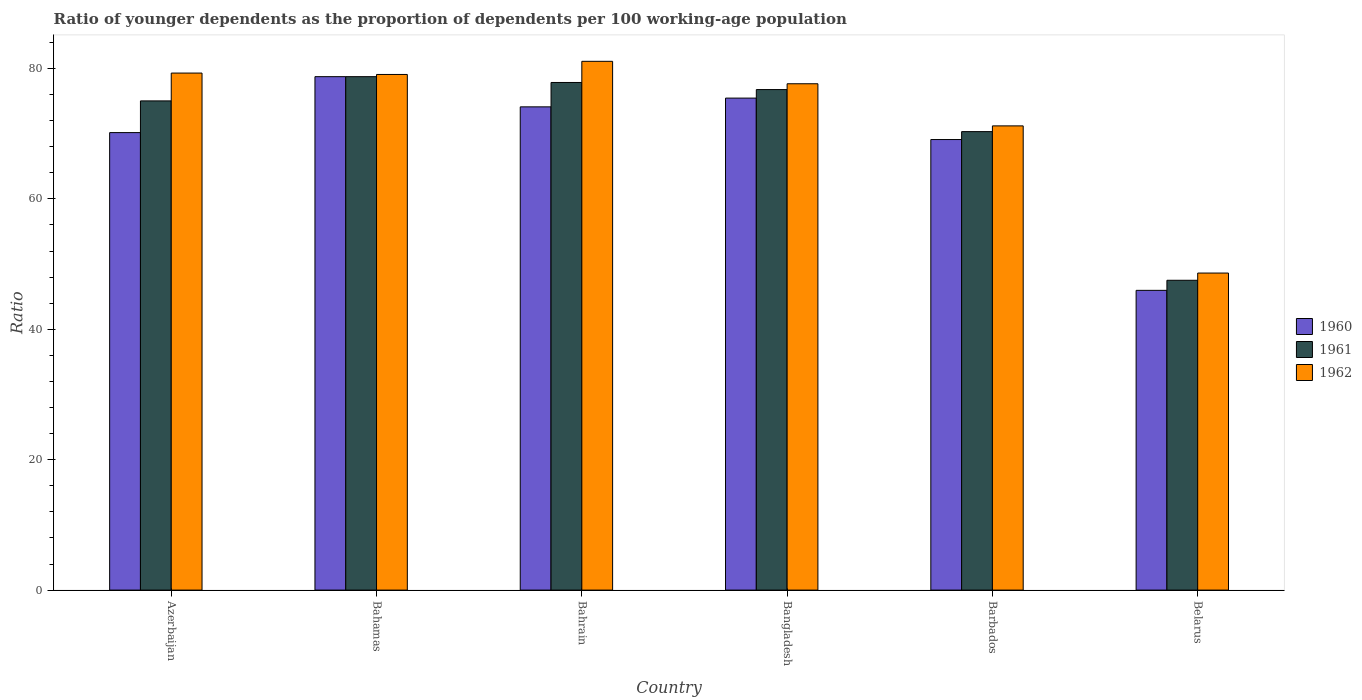How many groups of bars are there?
Give a very brief answer. 6. Are the number of bars per tick equal to the number of legend labels?
Your answer should be compact. Yes. How many bars are there on the 1st tick from the right?
Provide a succinct answer. 3. What is the label of the 4th group of bars from the left?
Offer a very short reply. Bangladesh. In how many cases, is the number of bars for a given country not equal to the number of legend labels?
Offer a terse response. 0. What is the age dependency ratio(young) in 1962 in Barbados?
Your answer should be very brief. 71.2. Across all countries, what is the maximum age dependency ratio(young) in 1960?
Your answer should be very brief. 78.75. Across all countries, what is the minimum age dependency ratio(young) in 1961?
Your answer should be compact. 47.52. In which country was the age dependency ratio(young) in 1961 maximum?
Your response must be concise. Bahamas. In which country was the age dependency ratio(young) in 1961 minimum?
Provide a short and direct response. Belarus. What is the total age dependency ratio(young) in 1960 in the graph?
Provide a short and direct response. 413.56. What is the difference between the age dependency ratio(young) in 1961 in Azerbaijan and that in Bangladesh?
Your answer should be very brief. -1.74. What is the difference between the age dependency ratio(young) in 1962 in Barbados and the age dependency ratio(young) in 1961 in Azerbaijan?
Your answer should be very brief. -3.83. What is the average age dependency ratio(young) in 1960 per country?
Your response must be concise. 68.93. What is the difference between the age dependency ratio(young) of/in 1960 and age dependency ratio(young) of/in 1961 in Belarus?
Offer a terse response. -1.55. What is the ratio of the age dependency ratio(young) in 1961 in Bahrain to that in Bangladesh?
Make the answer very short. 1.01. Is the difference between the age dependency ratio(young) in 1960 in Bangladesh and Belarus greater than the difference between the age dependency ratio(young) in 1961 in Bangladesh and Belarus?
Ensure brevity in your answer.  Yes. What is the difference between the highest and the second highest age dependency ratio(young) in 1960?
Your answer should be compact. -1.34. What is the difference between the highest and the lowest age dependency ratio(young) in 1962?
Provide a short and direct response. 32.48. In how many countries, is the age dependency ratio(young) in 1962 greater than the average age dependency ratio(young) in 1962 taken over all countries?
Make the answer very short. 4. Is the sum of the age dependency ratio(young) in 1962 in Azerbaijan and Bahrain greater than the maximum age dependency ratio(young) in 1960 across all countries?
Offer a very short reply. Yes. Is it the case that in every country, the sum of the age dependency ratio(young) in 1960 and age dependency ratio(young) in 1962 is greater than the age dependency ratio(young) in 1961?
Give a very brief answer. Yes. Are all the bars in the graph horizontal?
Offer a very short reply. No. What is the difference between two consecutive major ticks on the Y-axis?
Your answer should be compact. 20. Are the values on the major ticks of Y-axis written in scientific E-notation?
Your answer should be compact. No. Does the graph contain grids?
Provide a succinct answer. No. Where does the legend appear in the graph?
Provide a succinct answer. Center right. How are the legend labels stacked?
Provide a succinct answer. Vertical. What is the title of the graph?
Keep it short and to the point. Ratio of younger dependents as the proportion of dependents per 100 working-age population. Does "1991" appear as one of the legend labels in the graph?
Your answer should be compact. No. What is the label or title of the Y-axis?
Your answer should be compact. Ratio. What is the Ratio of 1960 in Azerbaijan?
Offer a terse response. 70.17. What is the Ratio of 1961 in Azerbaijan?
Your response must be concise. 75.03. What is the Ratio of 1962 in Azerbaijan?
Provide a short and direct response. 79.3. What is the Ratio in 1960 in Bahamas?
Your answer should be compact. 78.75. What is the Ratio of 1961 in Bahamas?
Provide a short and direct response. 78.75. What is the Ratio in 1962 in Bahamas?
Keep it short and to the point. 79.08. What is the Ratio of 1960 in Bahrain?
Offer a terse response. 74.12. What is the Ratio of 1961 in Bahrain?
Make the answer very short. 77.85. What is the Ratio of 1962 in Bahrain?
Your answer should be compact. 81.1. What is the Ratio of 1960 in Bangladesh?
Make the answer very short. 75.46. What is the Ratio of 1961 in Bangladesh?
Make the answer very short. 76.77. What is the Ratio of 1962 in Bangladesh?
Offer a terse response. 77.66. What is the Ratio in 1960 in Barbados?
Give a very brief answer. 69.1. What is the Ratio of 1961 in Barbados?
Keep it short and to the point. 70.32. What is the Ratio in 1962 in Barbados?
Keep it short and to the point. 71.2. What is the Ratio of 1960 in Belarus?
Offer a very short reply. 45.97. What is the Ratio of 1961 in Belarus?
Your answer should be compact. 47.52. What is the Ratio in 1962 in Belarus?
Your response must be concise. 48.62. Across all countries, what is the maximum Ratio of 1960?
Provide a succinct answer. 78.75. Across all countries, what is the maximum Ratio in 1961?
Ensure brevity in your answer.  78.75. Across all countries, what is the maximum Ratio in 1962?
Provide a short and direct response. 81.1. Across all countries, what is the minimum Ratio of 1960?
Offer a very short reply. 45.97. Across all countries, what is the minimum Ratio of 1961?
Keep it short and to the point. 47.52. Across all countries, what is the minimum Ratio in 1962?
Provide a short and direct response. 48.62. What is the total Ratio of 1960 in the graph?
Give a very brief answer. 413.56. What is the total Ratio in 1961 in the graph?
Offer a terse response. 426.23. What is the total Ratio in 1962 in the graph?
Keep it short and to the point. 436.96. What is the difference between the Ratio in 1960 in Azerbaijan and that in Bahamas?
Give a very brief answer. -8.58. What is the difference between the Ratio of 1961 in Azerbaijan and that in Bahamas?
Give a very brief answer. -3.72. What is the difference between the Ratio of 1962 in Azerbaijan and that in Bahamas?
Your answer should be compact. 0.21. What is the difference between the Ratio of 1960 in Azerbaijan and that in Bahrain?
Ensure brevity in your answer.  -3.95. What is the difference between the Ratio in 1961 in Azerbaijan and that in Bahrain?
Provide a short and direct response. -2.83. What is the difference between the Ratio of 1962 in Azerbaijan and that in Bahrain?
Your answer should be very brief. -1.8. What is the difference between the Ratio in 1960 in Azerbaijan and that in Bangladesh?
Your answer should be compact. -5.29. What is the difference between the Ratio in 1961 in Azerbaijan and that in Bangladesh?
Offer a terse response. -1.74. What is the difference between the Ratio of 1962 in Azerbaijan and that in Bangladesh?
Provide a short and direct response. 1.64. What is the difference between the Ratio in 1960 in Azerbaijan and that in Barbados?
Offer a terse response. 1.06. What is the difference between the Ratio in 1961 in Azerbaijan and that in Barbados?
Make the answer very short. 4.71. What is the difference between the Ratio in 1962 in Azerbaijan and that in Barbados?
Offer a terse response. 8.1. What is the difference between the Ratio in 1960 in Azerbaijan and that in Belarus?
Your answer should be very brief. 24.2. What is the difference between the Ratio of 1961 in Azerbaijan and that in Belarus?
Ensure brevity in your answer.  27.51. What is the difference between the Ratio in 1962 in Azerbaijan and that in Belarus?
Make the answer very short. 30.67. What is the difference between the Ratio of 1960 in Bahamas and that in Bahrain?
Make the answer very short. 4.63. What is the difference between the Ratio in 1961 in Bahamas and that in Bahrain?
Ensure brevity in your answer.  0.89. What is the difference between the Ratio in 1962 in Bahamas and that in Bahrain?
Offer a very short reply. -2.02. What is the difference between the Ratio of 1960 in Bahamas and that in Bangladesh?
Provide a succinct answer. 3.29. What is the difference between the Ratio in 1961 in Bahamas and that in Bangladesh?
Provide a succinct answer. 1.98. What is the difference between the Ratio of 1962 in Bahamas and that in Bangladesh?
Make the answer very short. 1.43. What is the difference between the Ratio in 1960 in Bahamas and that in Barbados?
Your answer should be compact. 9.64. What is the difference between the Ratio of 1961 in Bahamas and that in Barbados?
Offer a very short reply. 8.43. What is the difference between the Ratio in 1962 in Bahamas and that in Barbados?
Offer a very short reply. 7.89. What is the difference between the Ratio in 1960 in Bahamas and that in Belarus?
Provide a succinct answer. 32.77. What is the difference between the Ratio in 1961 in Bahamas and that in Belarus?
Your answer should be very brief. 31.23. What is the difference between the Ratio of 1962 in Bahamas and that in Belarus?
Ensure brevity in your answer.  30.46. What is the difference between the Ratio of 1960 in Bahrain and that in Bangladesh?
Keep it short and to the point. -1.34. What is the difference between the Ratio in 1961 in Bahrain and that in Bangladesh?
Offer a terse response. 1.09. What is the difference between the Ratio of 1962 in Bahrain and that in Bangladesh?
Your answer should be compact. 3.44. What is the difference between the Ratio in 1960 in Bahrain and that in Barbados?
Provide a succinct answer. 5.01. What is the difference between the Ratio of 1961 in Bahrain and that in Barbados?
Provide a short and direct response. 7.54. What is the difference between the Ratio of 1962 in Bahrain and that in Barbados?
Offer a very short reply. 9.9. What is the difference between the Ratio in 1960 in Bahrain and that in Belarus?
Provide a short and direct response. 28.14. What is the difference between the Ratio in 1961 in Bahrain and that in Belarus?
Your answer should be compact. 30.34. What is the difference between the Ratio in 1962 in Bahrain and that in Belarus?
Give a very brief answer. 32.48. What is the difference between the Ratio of 1960 in Bangladesh and that in Barbados?
Provide a succinct answer. 6.36. What is the difference between the Ratio of 1961 in Bangladesh and that in Barbados?
Your response must be concise. 6.45. What is the difference between the Ratio in 1962 in Bangladesh and that in Barbados?
Ensure brevity in your answer.  6.46. What is the difference between the Ratio of 1960 in Bangladesh and that in Belarus?
Make the answer very short. 29.49. What is the difference between the Ratio of 1961 in Bangladesh and that in Belarus?
Your answer should be compact. 29.25. What is the difference between the Ratio in 1962 in Bangladesh and that in Belarus?
Ensure brevity in your answer.  29.03. What is the difference between the Ratio in 1960 in Barbados and that in Belarus?
Your answer should be compact. 23.13. What is the difference between the Ratio of 1961 in Barbados and that in Belarus?
Keep it short and to the point. 22.8. What is the difference between the Ratio of 1962 in Barbados and that in Belarus?
Make the answer very short. 22.57. What is the difference between the Ratio in 1960 in Azerbaijan and the Ratio in 1961 in Bahamas?
Your answer should be compact. -8.58. What is the difference between the Ratio of 1960 in Azerbaijan and the Ratio of 1962 in Bahamas?
Provide a succinct answer. -8.92. What is the difference between the Ratio of 1961 in Azerbaijan and the Ratio of 1962 in Bahamas?
Provide a succinct answer. -4.06. What is the difference between the Ratio in 1960 in Azerbaijan and the Ratio in 1961 in Bahrain?
Offer a terse response. -7.69. What is the difference between the Ratio of 1960 in Azerbaijan and the Ratio of 1962 in Bahrain?
Your response must be concise. -10.93. What is the difference between the Ratio of 1961 in Azerbaijan and the Ratio of 1962 in Bahrain?
Offer a terse response. -6.07. What is the difference between the Ratio of 1960 in Azerbaijan and the Ratio of 1961 in Bangladesh?
Provide a short and direct response. -6.6. What is the difference between the Ratio in 1960 in Azerbaijan and the Ratio in 1962 in Bangladesh?
Offer a very short reply. -7.49. What is the difference between the Ratio in 1961 in Azerbaijan and the Ratio in 1962 in Bangladesh?
Provide a succinct answer. -2.63. What is the difference between the Ratio in 1960 in Azerbaijan and the Ratio in 1961 in Barbados?
Keep it short and to the point. -0.15. What is the difference between the Ratio of 1960 in Azerbaijan and the Ratio of 1962 in Barbados?
Your answer should be compact. -1.03. What is the difference between the Ratio of 1961 in Azerbaijan and the Ratio of 1962 in Barbados?
Ensure brevity in your answer.  3.83. What is the difference between the Ratio of 1960 in Azerbaijan and the Ratio of 1961 in Belarus?
Provide a succinct answer. 22.65. What is the difference between the Ratio in 1960 in Azerbaijan and the Ratio in 1962 in Belarus?
Offer a terse response. 21.54. What is the difference between the Ratio in 1961 in Azerbaijan and the Ratio in 1962 in Belarus?
Keep it short and to the point. 26.4. What is the difference between the Ratio in 1960 in Bahamas and the Ratio in 1961 in Bahrain?
Provide a succinct answer. 0.89. What is the difference between the Ratio in 1960 in Bahamas and the Ratio in 1962 in Bahrain?
Provide a succinct answer. -2.35. What is the difference between the Ratio of 1961 in Bahamas and the Ratio of 1962 in Bahrain?
Your response must be concise. -2.35. What is the difference between the Ratio of 1960 in Bahamas and the Ratio of 1961 in Bangladesh?
Ensure brevity in your answer.  1.98. What is the difference between the Ratio of 1960 in Bahamas and the Ratio of 1962 in Bangladesh?
Keep it short and to the point. 1.09. What is the difference between the Ratio of 1961 in Bahamas and the Ratio of 1962 in Bangladesh?
Your answer should be very brief. 1.09. What is the difference between the Ratio in 1960 in Bahamas and the Ratio in 1961 in Barbados?
Give a very brief answer. 8.43. What is the difference between the Ratio of 1960 in Bahamas and the Ratio of 1962 in Barbados?
Provide a short and direct response. 7.55. What is the difference between the Ratio of 1961 in Bahamas and the Ratio of 1962 in Barbados?
Provide a succinct answer. 7.55. What is the difference between the Ratio in 1960 in Bahamas and the Ratio in 1961 in Belarus?
Keep it short and to the point. 31.23. What is the difference between the Ratio in 1960 in Bahamas and the Ratio in 1962 in Belarus?
Make the answer very short. 30.12. What is the difference between the Ratio of 1961 in Bahamas and the Ratio of 1962 in Belarus?
Offer a very short reply. 30.12. What is the difference between the Ratio in 1960 in Bahrain and the Ratio in 1961 in Bangladesh?
Provide a succinct answer. -2.65. What is the difference between the Ratio of 1960 in Bahrain and the Ratio of 1962 in Bangladesh?
Provide a succinct answer. -3.54. What is the difference between the Ratio in 1961 in Bahrain and the Ratio in 1962 in Bangladesh?
Give a very brief answer. 0.2. What is the difference between the Ratio of 1960 in Bahrain and the Ratio of 1961 in Barbados?
Give a very brief answer. 3.8. What is the difference between the Ratio in 1960 in Bahrain and the Ratio in 1962 in Barbados?
Offer a terse response. 2.92. What is the difference between the Ratio in 1961 in Bahrain and the Ratio in 1962 in Barbados?
Give a very brief answer. 6.66. What is the difference between the Ratio in 1960 in Bahrain and the Ratio in 1961 in Belarus?
Your answer should be very brief. 26.6. What is the difference between the Ratio of 1960 in Bahrain and the Ratio of 1962 in Belarus?
Ensure brevity in your answer.  25.49. What is the difference between the Ratio of 1961 in Bahrain and the Ratio of 1962 in Belarus?
Provide a succinct answer. 29.23. What is the difference between the Ratio of 1960 in Bangladesh and the Ratio of 1961 in Barbados?
Make the answer very short. 5.14. What is the difference between the Ratio of 1960 in Bangladesh and the Ratio of 1962 in Barbados?
Ensure brevity in your answer.  4.26. What is the difference between the Ratio in 1961 in Bangladesh and the Ratio in 1962 in Barbados?
Your answer should be very brief. 5.57. What is the difference between the Ratio of 1960 in Bangladesh and the Ratio of 1961 in Belarus?
Give a very brief answer. 27.94. What is the difference between the Ratio in 1960 in Bangladesh and the Ratio in 1962 in Belarus?
Your answer should be compact. 26.83. What is the difference between the Ratio in 1961 in Bangladesh and the Ratio in 1962 in Belarus?
Give a very brief answer. 28.14. What is the difference between the Ratio of 1960 in Barbados and the Ratio of 1961 in Belarus?
Offer a very short reply. 21.58. What is the difference between the Ratio of 1960 in Barbados and the Ratio of 1962 in Belarus?
Give a very brief answer. 20.48. What is the difference between the Ratio in 1961 in Barbados and the Ratio in 1962 in Belarus?
Your response must be concise. 21.69. What is the average Ratio of 1960 per country?
Your response must be concise. 68.93. What is the average Ratio in 1961 per country?
Give a very brief answer. 71.04. What is the average Ratio in 1962 per country?
Provide a short and direct response. 72.83. What is the difference between the Ratio in 1960 and Ratio in 1961 in Azerbaijan?
Your answer should be very brief. -4.86. What is the difference between the Ratio of 1960 and Ratio of 1962 in Azerbaijan?
Offer a very short reply. -9.13. What is the difference between the Ratio of 1961 and Ratio of 1962 in Azerbaijan?
Your response must be concise. -4.27. What is the difference between the Ratio in 1960 and Ratio in 1961 in Bahamas?
Your answer should be very brief. 0. What is the difference between the Ratio of 1960 and Ratio of 1962 in Bahamas?
Provide a short and direct response. -0.34. What is the difference between the Ratio in 1961 and Ratio in 1962 in Bahamas?
Ensure brevity in your answer.  -0.34. What is the difference between the Ratio in 1960 and Ratio in 1961 in Bahrain?
Offer a terse response. -3.74. What is the difference between the Ratio in 1960 and Ratio in 1962 in Bahrain?
Your response must be concise. -6.98. What is the difference between the Ratio of 1961 and Ratio of 1962 in Bahrain?
Give a very brief answer. -3.25. What is the difference between the Ratio in 1960 and Ratio in 1961 in Bangladesh?
Your response must be concise. -1.31. What is the difference between the Ratio in 1960 and Ratio in 1962 in Bangladesh?
Offer a terse response. -2.2. What is the difference between the Ratio in 1961 and Ratio in 1962 in Bangladesh?
Your response must be concise. -0.89. What is the difference between the Ratio in 1960 and Ratio in 1961 in Barbados?
Provide a succinct answer. -1.22. What is the difference between the Ratio in 1960 and Ratio in 1962 in Barbados?
Provide a short and direct response. -2.1. What is the difference between the Ratio in 1961 and Ratio in 1962 in Barbados?
Your answer should be compact. -0.88. What is the difference between the Ratio in 1960 and Ratio in 1961 in Belarus?
Make the answer very short. -1.55. What is the difference between the Ratio in 1960 and Ratio in 1962 in Belarus?
Give a very brief answer. -2.65. What is the difference between the Ratio in 1961 and Ratio in 1962 in Belarus?
Ensure brevity in your answer.  -1.11. What is the ratio of the Ratio in 1960 in Azerbaijan to that in Bahamas?
Keep it short and to the point. 0.89. What is the ratio of the Ratio of 1961 in Azerbaijan to that in Bahamas?
Ensure brevity in your answer.  0.95. What is the ratio of the Ratio of 1960 in Azerbaijan to that in Bahrain?
Make the answer very short. 0.95. What is the ratio of the Ratio in 1961 in Azerbaijan to that in Bahrain?
Provide a short and direct response. 0.96. What is the ratio of the Ratio of 1962 in Azerbaijan to that in Bahrain?
Provide a short and direct response. 0.98. What is the ratio of the Ratio of 1960 in Azerbaijan to that in Bangladesh?
Offer a very short reply. 0.93. What is the ratio of the Ratio of 1961 in Azerbaijan to that in Bangladesh?
Provide a short and direct response. 0.98. What is the ratio of the Ratio in 1962 in Azerbaijan to that in Bangladesh?
Offer a terse response. 1.02. What is the ratio of the Ratio of 1960 in Azerbaijan to that in Barbados?
Keep it short and to the point. 1.02. What is the ratio of the Ratio of 1961 in Azerbaijan to that in Barbados?
Your answer should be very brief. 1.07. What is the ratio of the Ratio of 1962 in Azerbaijan to that in Barbados?
Make the answer very short. 1.11. What is the ratio of the Ratio of 1960 in Azerbaijan to that in Belarus?
Offer a very short reply. 1.53. What is the ratio of the Ratio in 1961 in Azerbaijan to that in Belarus?
Offer a terse response. 1.58. What is the ratio of the Ratio of 1962 in Azerbaijan to that in Belarus?
Offer a terse response. 1.63. What is the ratio of the Ratio of 1960 in Bahamas to that in Bahrain?
Give a very brief answer. 1.06. What is the ratio of the Ratio of 1961 in Bahamas to that in Bahrain?
Provide a succinct answer. 1.01. What is the ratio of the Ratio in 1962 in Bahamas to that in Bahrain?
Your answer should be very brief. 0.98. What is the ratio of the Ratio of 1960 in Bahamas to that in Bangladesh?
Provide a succinct answer. 1.04. What is the ratio of the Ratio in 1961 in Bahamas to that in Bangladesh?
Your answer should be compact. 1.03. What is the ratio of the Ratio in 1962 in Bahamas to that in Bangladesh?
Ensure brevity in your answer.  1.02. What is the ratio of the Ratio of 1960 in Bahamas to that in Barbados?
Your response must be concise. 1.14. What is the ratio of the Ratio in 1961 in Bahamas to that in Barbados?
Make the answer very short. 1.12. What is the ratio of the Ratio in 1962 in Bahamas to that in Barbados?
Ensure brevity in your answer.  1.11. What is the ratio of the Ratio of 1960 in Bahamas to that in Belarus?
Keep it short and to the point. 1.71. What is the ratio of the Ratio in 1961 in Bahamas to that in Belarus?
Ensure brevity in your answer.  1.66. What is the ratio of the Ratio of 1962 in Bahamas to that in Belarus?
Offer a very short reply. 1.63. What is the ratio of the Ratio of 1960 in Bahrain to that in Bangladesh?
Offer a very short reply. 0.98. What is the ratio of the Ratio in 1961 in Bahrain to that in Bangladesh?
Your answer should be compact. 1.01. What is the ratio of the Ratio in 1962 in Bahrain to that in Bangladesh?
Your answer should be very brief. 1.04. What is the ratio of the Ratio of 1960 in Bahrain to that in Barbados?
Keep it short and to the point. 1.07. What is the ratio of the Ratio in 1961 in Bahrain to that in Barbados?
Provide a short and direct response. 1.11. What is the ratio of the Ratio in 1962 in Bahrain to that in Barbados?
Offer a very short reply. 1.14. What is the ratio of the Ratio in 1960 in Bahrain to that in Belarus?
Ensure brevity in your answer.  1.61. What is the ratio of the Ratio of 1961 in Bahrain to that in Belarus?
Make the answer very short. 1.64. What is the ratio of the Ratio in 1962 in Bahrain to that in Belarus?
Provide a short and direct response. 1.67. What is the ratio of the Ratio in 1960 in Bangladesh to that in Barbados?
Ensure brevity in your answer.  1.09. What is the ratio of the Ratio of 1961 in Bangladesh to that in Barbados?
Provide a short and direct response. 1.09. What is the ratio of the Ratio of 1962 in Bangladesh to that in Barbados?
Your answer should be compact. 1.09. What is the ratio of the Ratio in 1960 in Bangladesh to that in Belarus?
Your response must be concise. 1.64. What is the ratio of the Ratio of 1961 in Bangladesh to that in Belarus?
Provide a succinct answer. 1.62. What is the ratio of the Ratio of 1962 in Bangladesh to that in Belarus?
Provide a succinct answer. 1.6. What is the ratio of the Ratio of 1960 in Barbados to that in Belarus?
Your answer should be compact. 1.5. What is the ratio of the Ratio in 1961 in Barbados to that in Belarus?
Offer a terse response. 1.48. What is the ratio of the Ratio in 1962 in Barbados to that in Belarus?
Provide a succinct answer. 1.46. What is the difference between the highest and the second highest Ratio in 1960?
Your answer should be compact. 3.29. What is the difference between the highest and the second highest Ratio of 1961?
Your answer should be compact. 0.89. What is the difference between the highest and the second highest Ratio in 1962?
Give a very brief answer. 1.8. What is the difference between the highest and the lowest Ratio of 1960?
Make the answer very short. 32.77. What is the difference between the highest and the lowest Ratio of 1961?
Make the answer very short. 31.23. What is the difference between the highest and the lowest Ratio in 1962?
Make the answer very short. 32.48. 